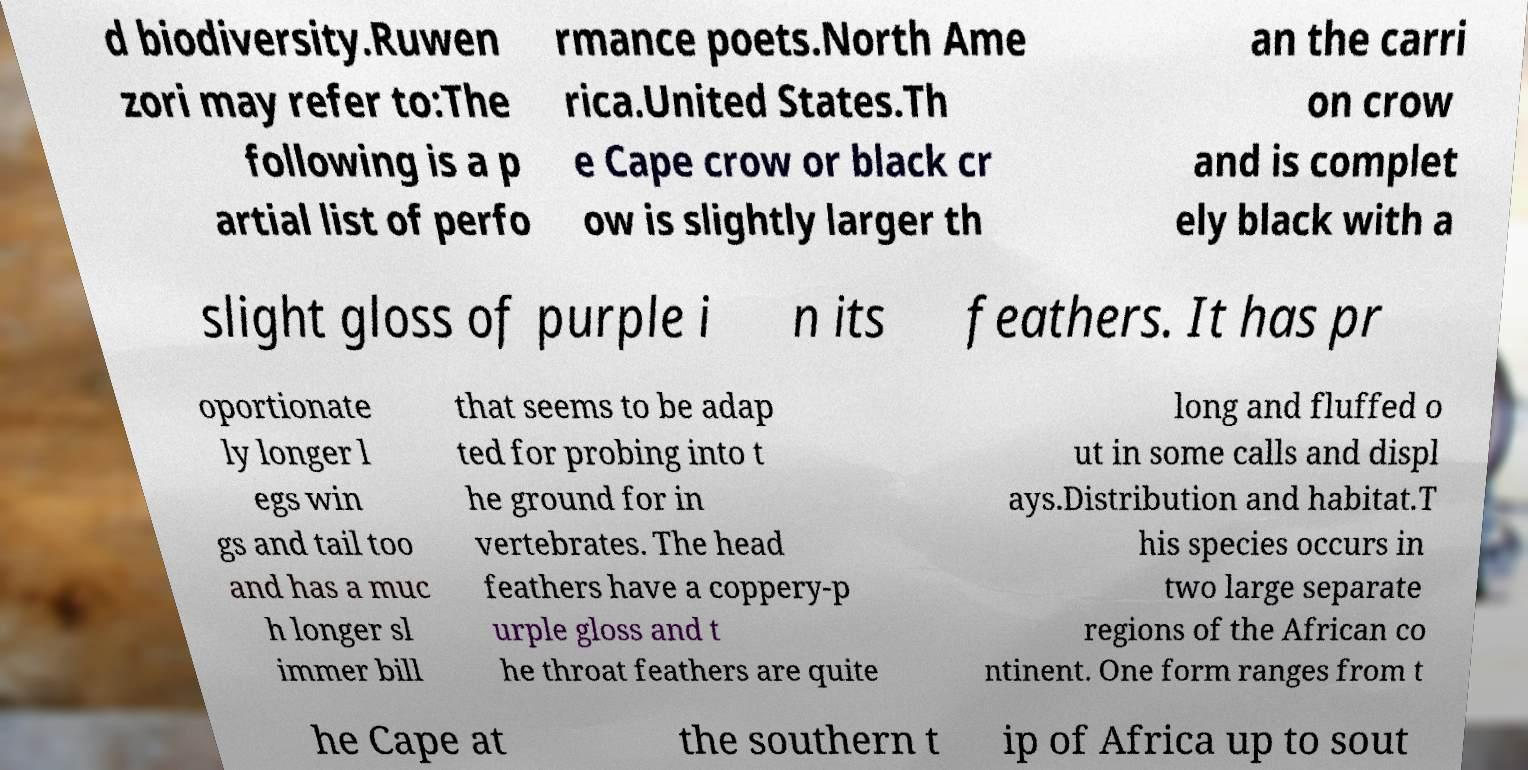Can you accurately transcribe the text from the provided image for me? d biodiversity.Ruwen zori may refer to:The following is a p artial list of perfo rmance poets.North Ame rica.United States.Th e Cape crow or black cr ow is slightly larger th an the carri on crow and is complet ely black with a slight gloss of purple i n its feathers. It has pr oportionate ly longer l egs win gs and tail too and has a muc h longer sl immer bill that seems to be adap ted for probing into t he ground for in vertebrates. The head feathers have a coppery-p urple gloss and t he throat feathers are quite long and fluffed o ut in some calls and displ ays.Distribution and habitat.T his species occurs in two large separate regions of the African co ntinent. One form ranges from t he Cape at the southern t ip of Africa up to sout 